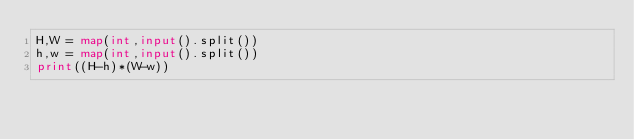Convert code to text. <code><loc_0><loc_0><loc_500><loc_500><_Python_>H,W = map(int,input().split())
h,w = map(int,input().split())
print((H-h)*(W-w))</code> 